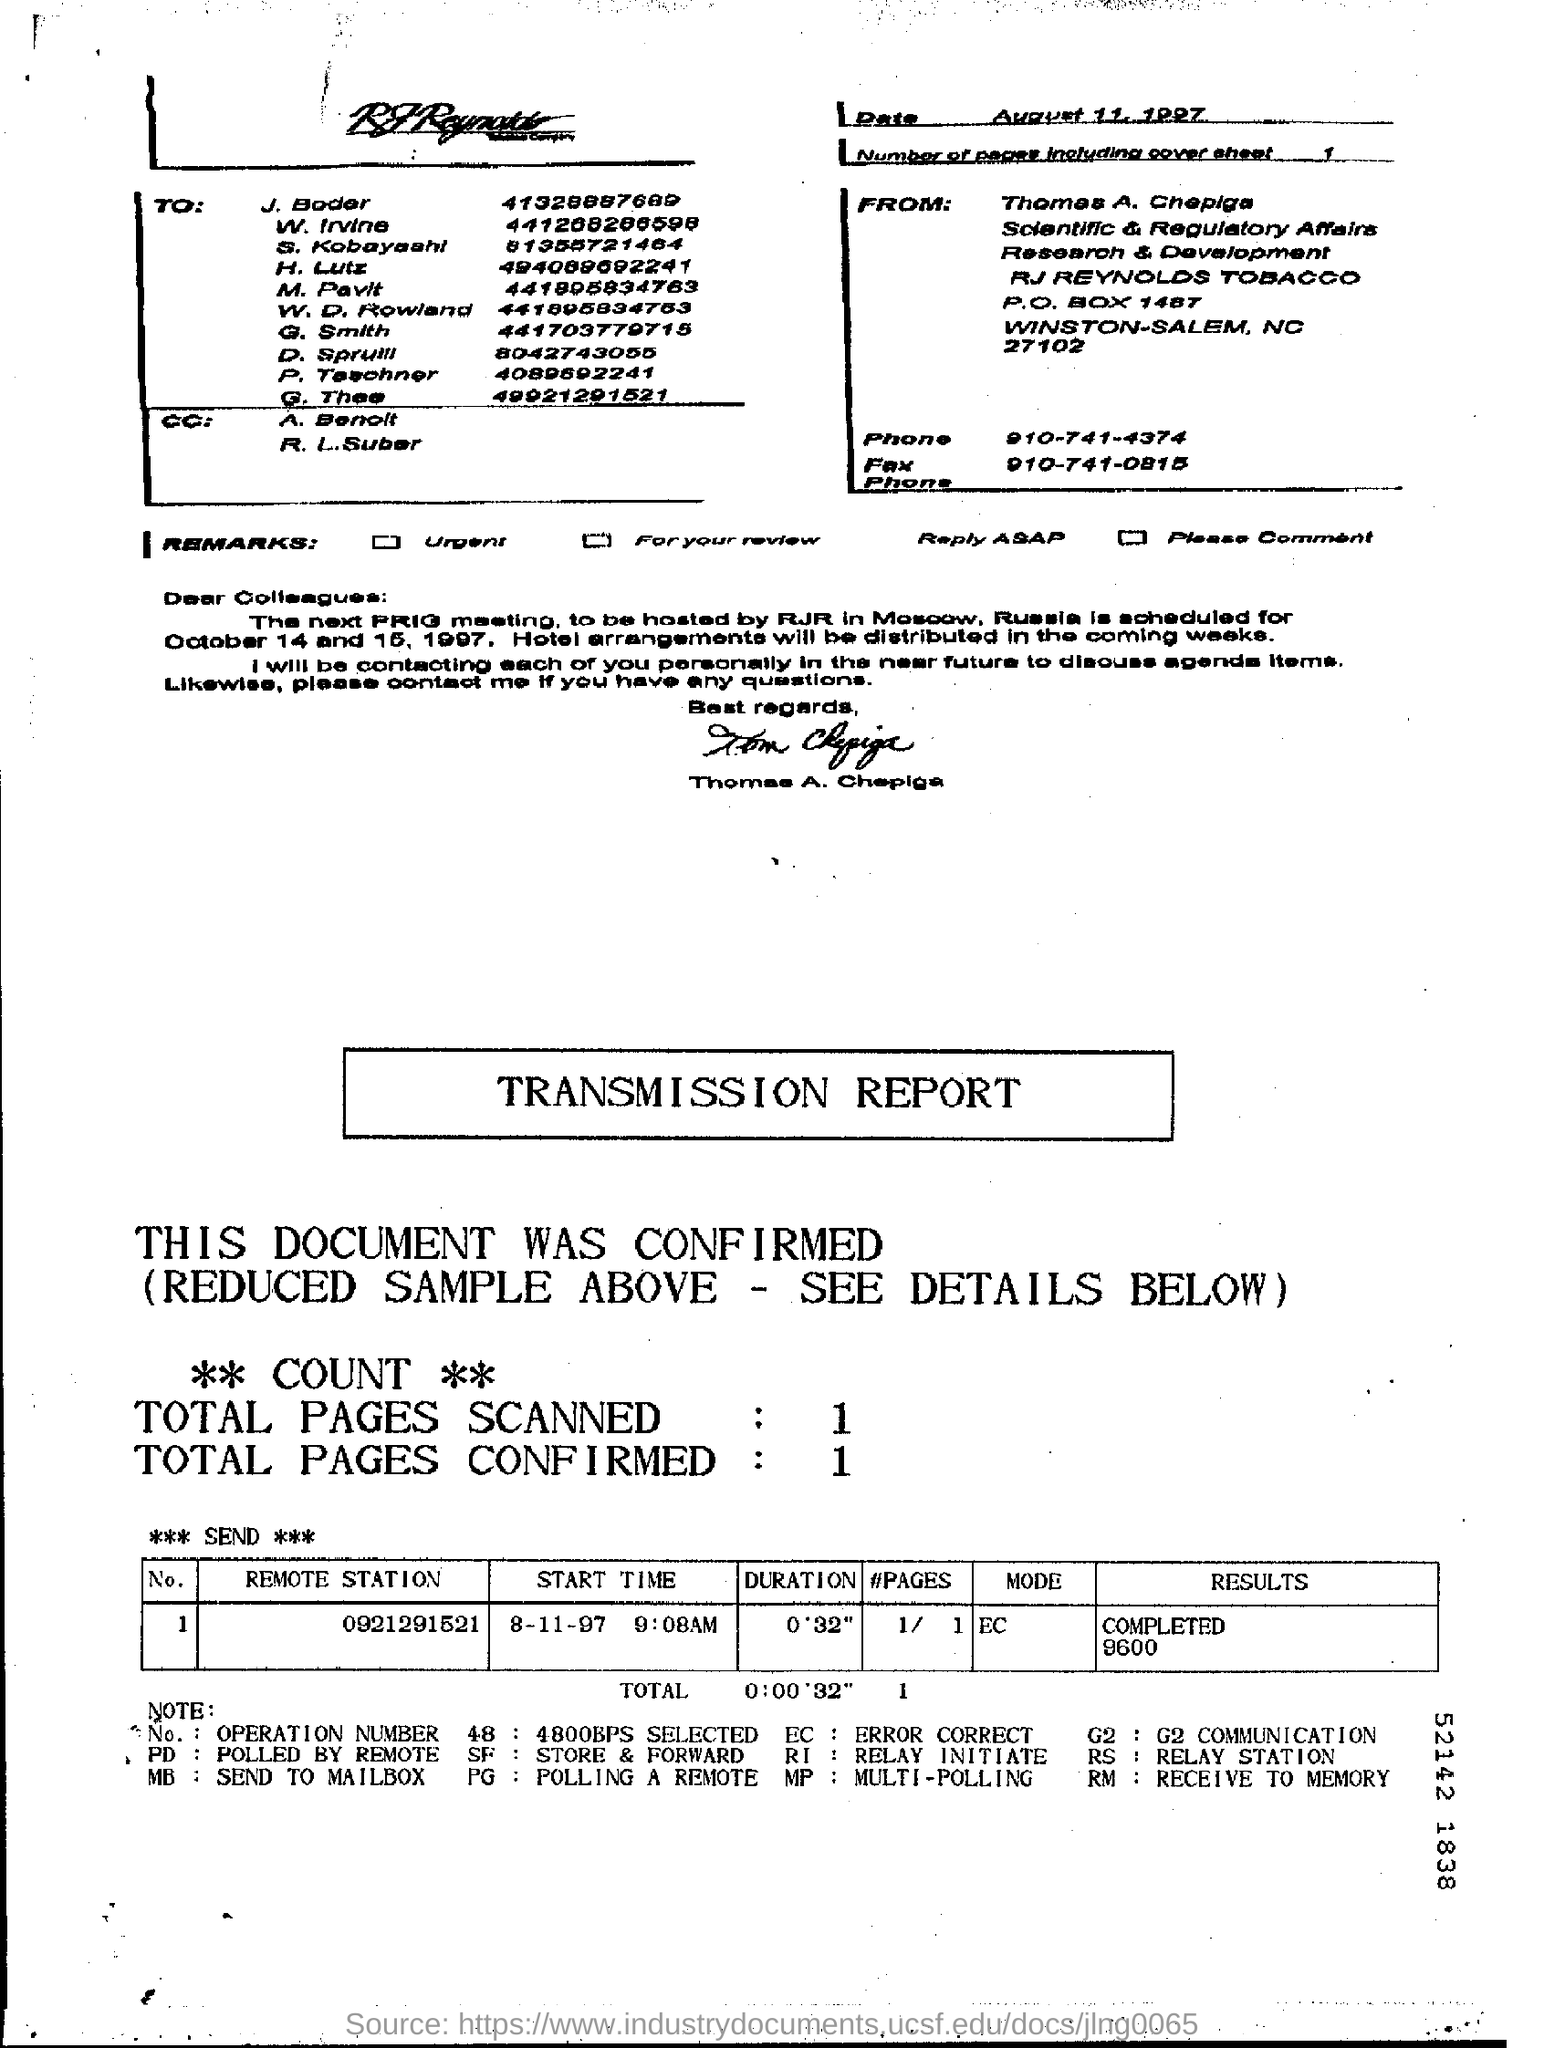Specify some key components in this picture. The total number of pages confirmed is 1.. The sender's phone number is 910-741-4374. The date mentioned on the cover sheet is August 11, 1997. The first name of the person who sent this communication is Thomas. The transmission includes the scanning of one page. 